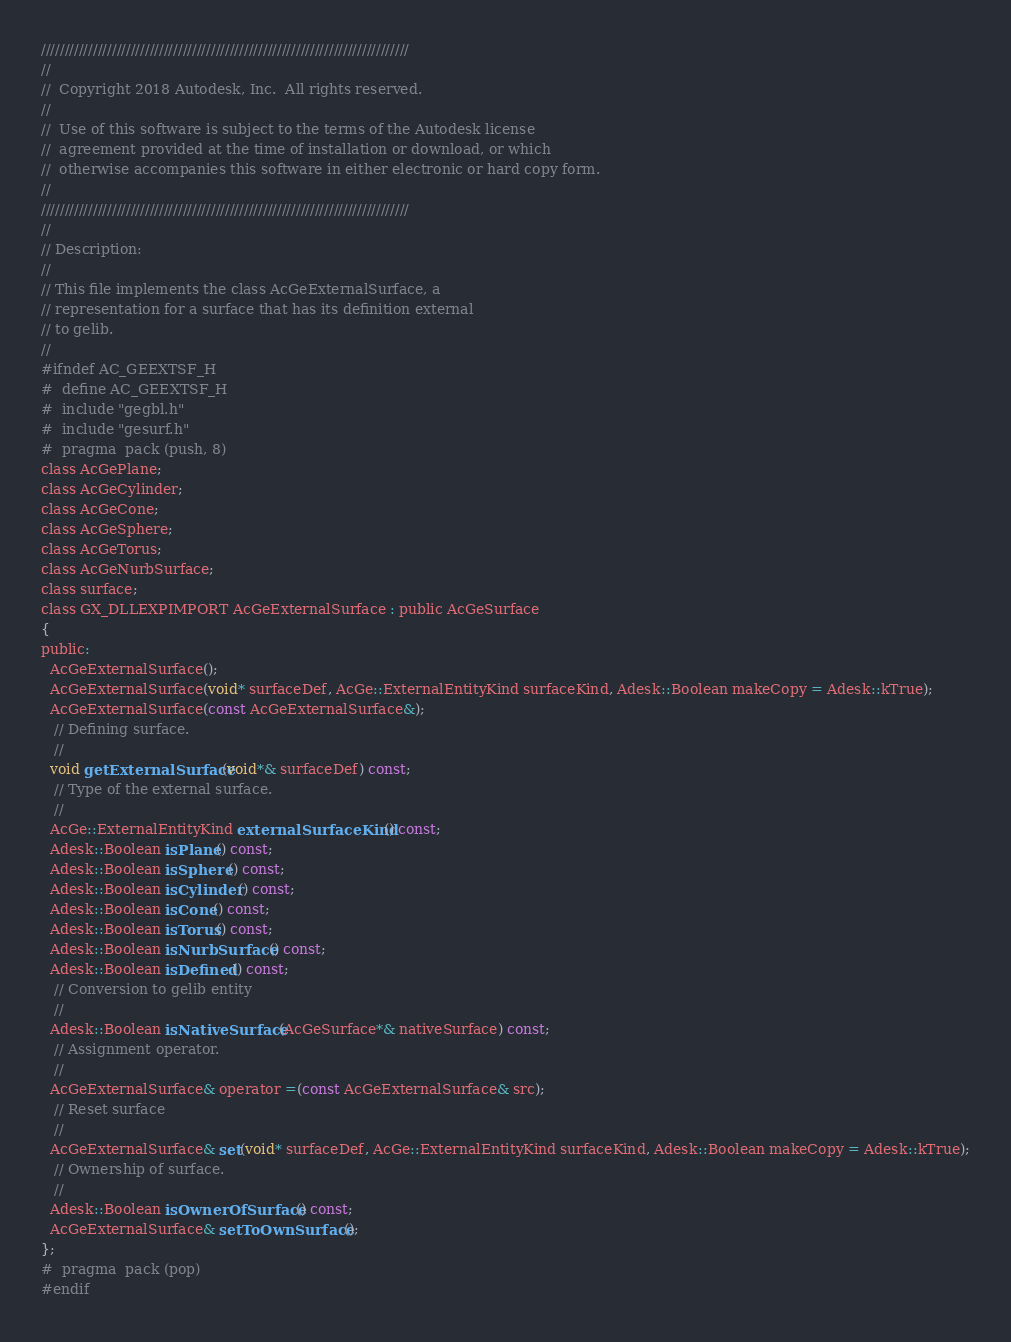<code> <loc_0><loc_0><loc_500><loc_500><_C_>//////////////////////////////////////////////////////////////////////////////
//
//  Copyright 2018 Autodesk, Inc.  All rights reserved.
//
//  Use of this software is subject to the terms of the Autodesk license 
//  agreement provided at the time of installation or download, or which 
//  otherwise accompanies this software in either electronic or hard copy form.   
//
//////////////////////////////////////////////////////////////////////////////
//
// Description:
//
// This file implements the class AcGeExternalSurface, a
// representation for a surface that has its definition external
// to gelib.
//
#ifndef AC_GEEXTSF_H
#  define AC_GEEXTSF_H
#  include "gegbl.h"
#  include "gesurf.h"
#  pragma  pack (push, 8)
class AcGePlane;
class AcGeCylinder;
class AcGeCone;
class AcGeSphere;
class AcGeTorus;
class AcGeNurbSurface;
class surface;
class GX_DLLEXPIMPORT AcGeExternalSurface : public AcGeSurface
{
public:
  AcGeExternalSurface();
  AcGeExternalSurface(void* surfaceDef, AcGe::ExternalEntityKind surfaceKind, Adesk::Boolean makeCopy = Adesk::kTrue);
  AcGeExternalSurface(const AcGeExternalSurface&);
   // Defining surface.
   //
  void getExternalSurface(void*& surfaceDef) const;
   // Type of the external surface.
   //
  AcGe::ExternalEntityKind externalSurfaceKind() const;
  Adesk::Boolean isPlane() const;
  Adesk::Boolean isSphere() const;
  Adesk::Boolean isCylinder() const;
  Adesk::Boolean isCone() const;
  Adesk::Boolean isTorus() const;
  Adesk::Boolean isNurbSurface() const;
  Adesk::Boolean isDefined() const;
   // Conversion to gelib entity
   //
  Adesk::Boolean isNativeSurface(AcGeSurface*& nativeSurface) const;
   // Assignment operator.
   //
  AcGeExternalSurface& operator =(const AcGeExternalSurface& src);
   // Reset surface
   //
  AcGeExternalSurface& set(void* surfaceDef, AcGe::ExternalEntityKind surfaceKind, Adesk::Boolean makeCopy = Adesk::kTrue);
   // Ownership of surface.
   //
  Adesk::Boolean isOwnerOfSurface() const;
  AcGeExternalSurface& setToOwnSurface();
};
#  pragma  pack (pop)
#endif
</code> 